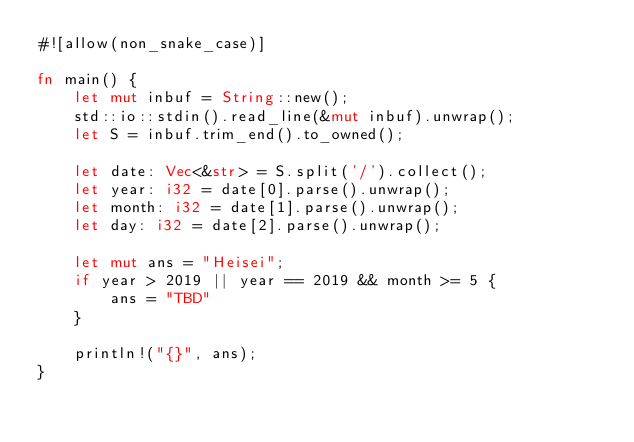Convert code to text. <code><loc_0><loc_0><loc_500><loc_500><_Rust_>#![allow(non_snake_case)]

fn main() {
    let mut inbuf = String::new();
    std::io::stdin().read_line(&mut inbuf).unwrap();
    let S = inbuf.trim_end().to_owned();

    let date: Vec<&str> = S.split('/').collect();
    let year: i32 = date[0].parse().unwrap();
    let month: i32 = date[1].parse().unwrap();
    let day: i32 = date[2].parse().unwrap();

    let mut ans = "Heisei";
    if year > 2019 || year == 2019 && month >= 5 {
        ans = "TBD"
    }

    println!("{}", ans);
}
</code> 